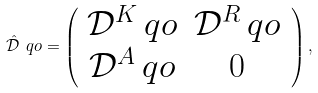Convert formula to latex. <formula><loc_0><loc_0><loc_500><loc_500>\hat { \mathcal { D } } \ q o = \left ( \begin{array} { c c } \mathcal { D } ^ { K } \ q o & \mathcal { D } ^ { R } \ q o \\ \mathcal { D } ^ { A } \ q o & 0 \end{array} \, \right ) , \,</formula> 